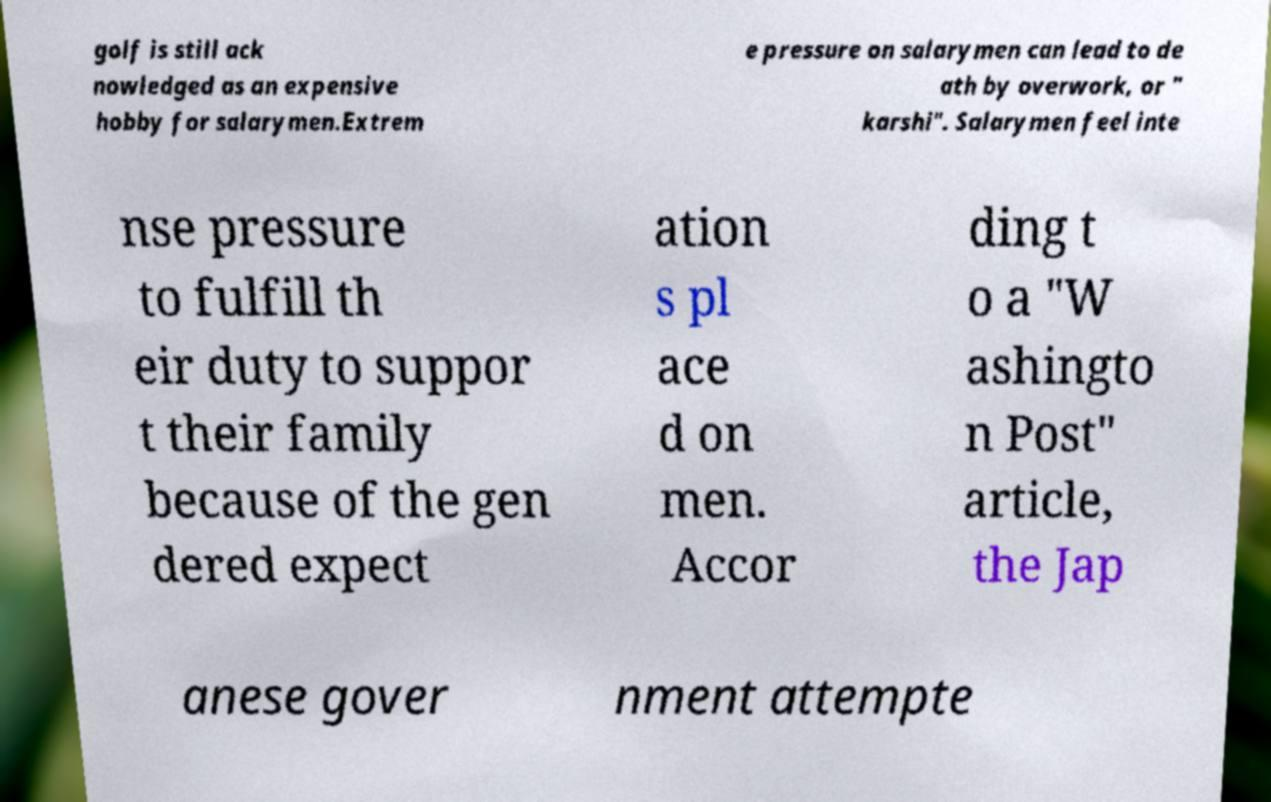Could you extract and type out the text from this image? golf is still ack nowledged as an expensive hobby for salarymen.Extrem e pressure on salarymen can lead to de ath by overwork, or " karshi". Salarymen feel inte nse pressure to fulfill th eir duty to suppor t their family because of the gen dered expect ation s pl ace d on men. Accor ding t o a "W ashingto n Post" article, the Jap anese gover nment attempte 